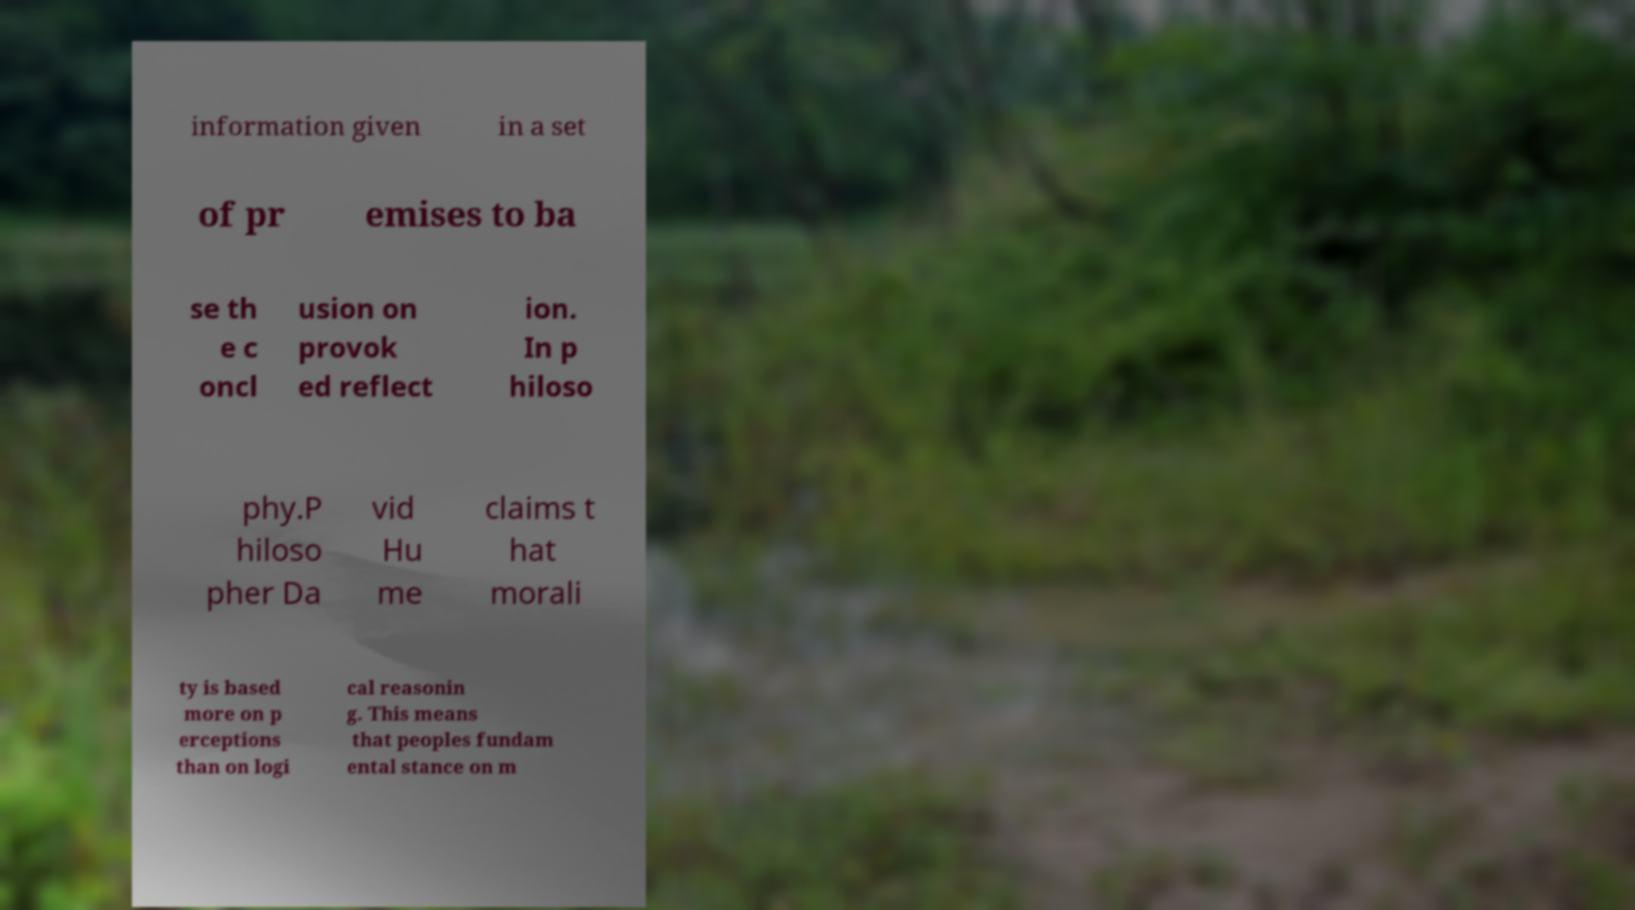Can you accurately transcribe the text from the provided image for me? information given in a set of pr emises to ba se th e c oncl usion on provok ed reflect ion. In p hiloso phy.P hiloso pher Da vid Hu me claims t hat morali ty is based more on p erceptions than on logi cal reasonin g. This means that peoples fundam ental stance on m 